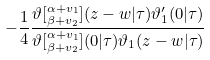Convert formula to latex. <formula><loc_0><loc_0><loc_500><loc_500>- \frac { 1 } { 4 } \frac { \vartheta [ ^ { \alpha + v _ { 1 } } _ { \beta + v _ { 2 } } ] ( z - w | \tau ) \vartheta _ { 1 } ^ { \prime } ( 0 | \tau ) } { \vartheta [ ^ { \alpha + v _ { 1 } } _ { \beta + v _ { 2 } } ] ( 0 | \tau ) \vartheta _ { 1 } ( z - w | \tau ) }</formula> 